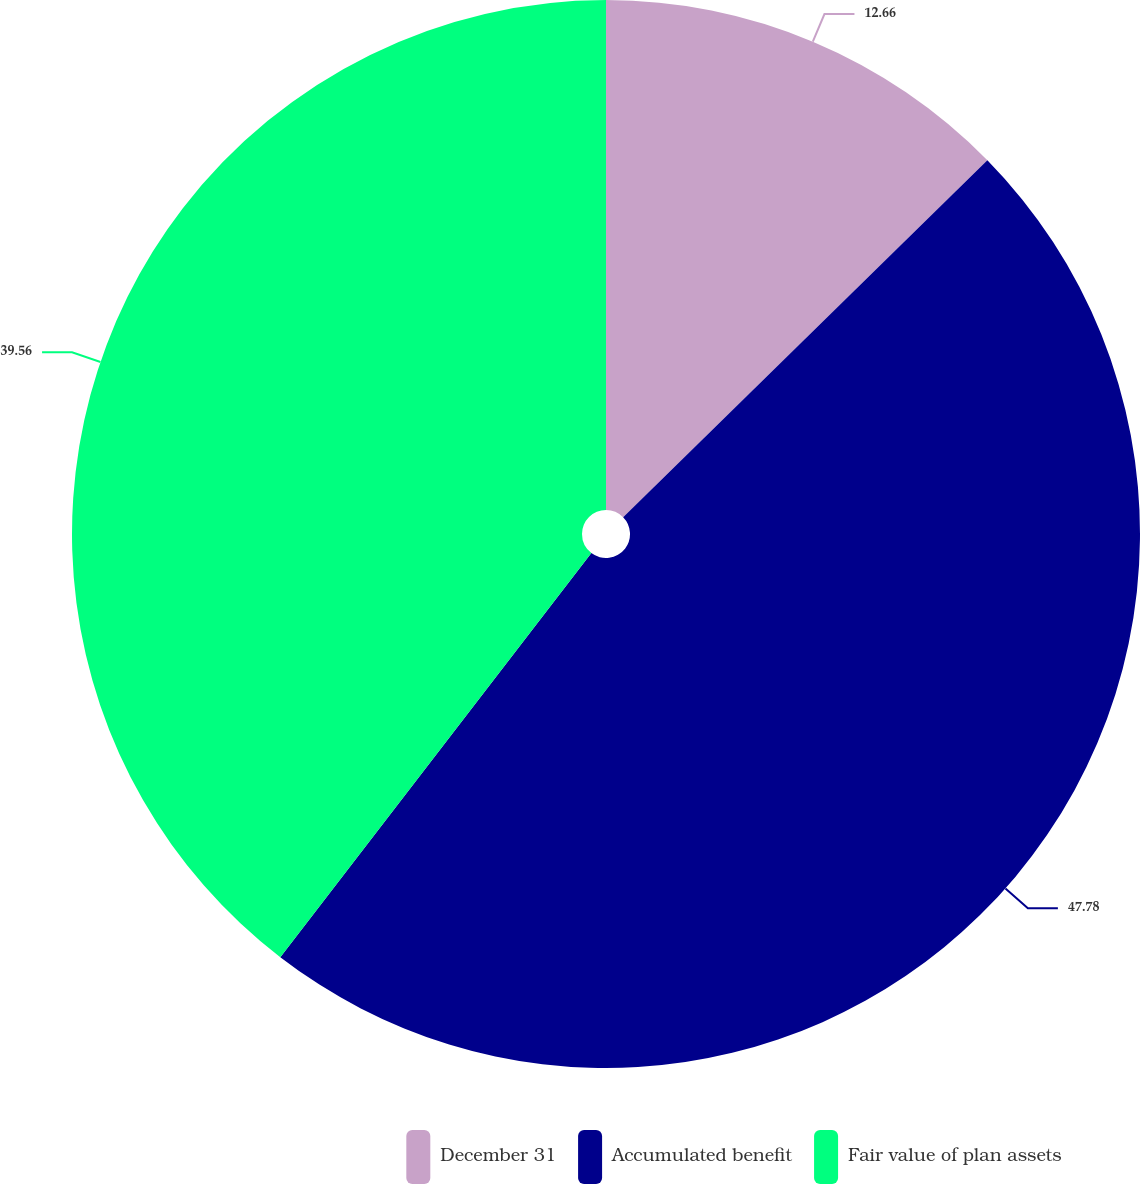<chart> <loc_0><loc_0><loc_500><loc_500><pie_chart><fcel>December 31<fcel>Accumulated benefit<fcel>Fair value of plan assets<nl><fcel>12.66%<fcel>47.78%<fcel>39.56%<nl></chart> 